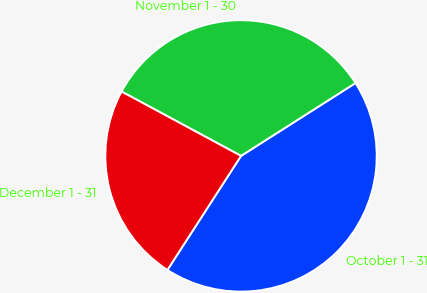Convert chart to OTSL. <chart><loc_0><loc_0><loc_500><loc_500><pie_chart><fcel>October 1 - 31<fcel>November 1 - 30<fcel>December 1 - 31<nl><fcel>43.15%<fcel>33.11%<fcel>23.74%<nl></chart> 